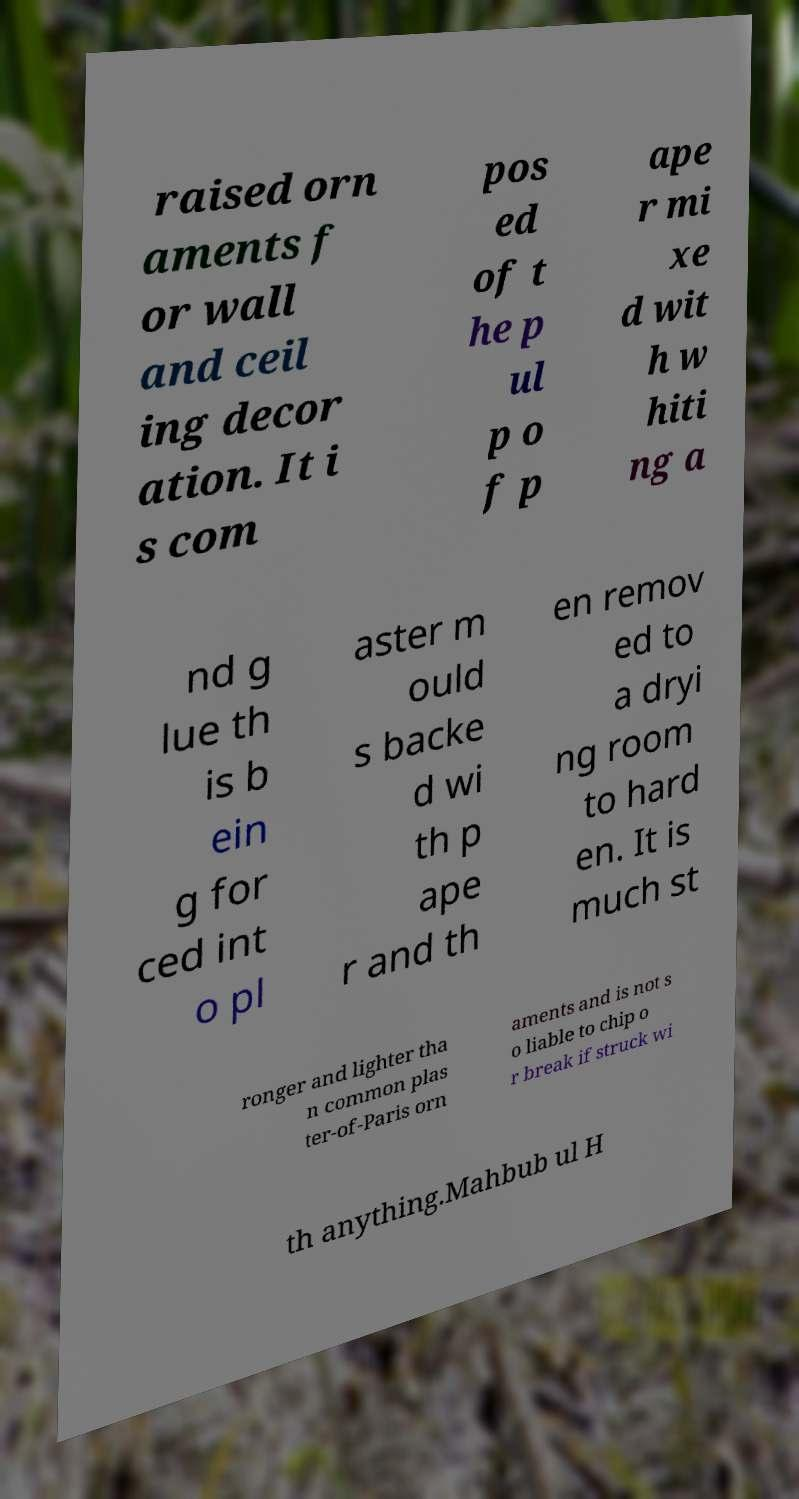Can you accurately transcribe the text from the provided image for me? raised orn aments f or wall and ceil ing decor ation. It i s com pos ed of t he p ul p o f p ape r mi xe d wit h w hiti ng a nd g lue th is b ein g for ced int o pl aster m ould s backe d wi th p ape r and th en remov ed to a dryi ng room to hard en. It is much st ronger and lighter tha n common plas ter-of-Paris orn aments and is not s o liable to chip o r break if struck wi th anything.Mahbub ul H 